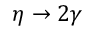Convert formula to latex. <formula><loc_0><loc_0><loc_500><loc_500>\eta \rightarrow 2 \gamma</formula> 